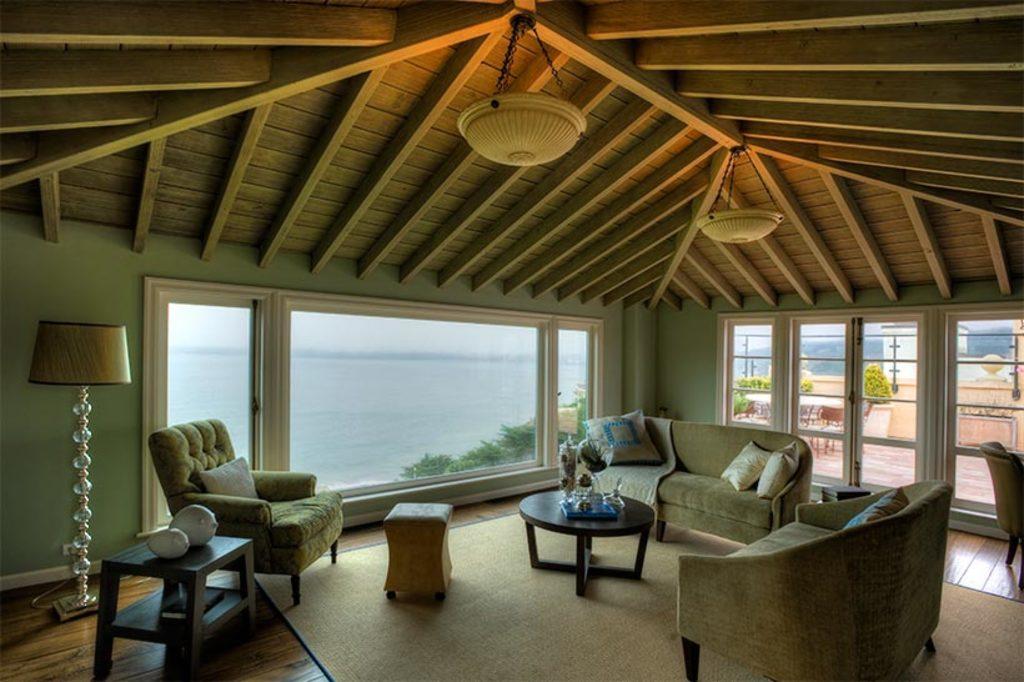Can you describe this image briefly? In the image we can see couch,sofa,table. On table,there is a flower vase,glasses and basket. In the background three is a wood wall,lamp,glass,table,chairs,lamp,water,trees and carpet. 